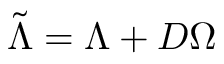Convert formula to latex. <formula><loc_0><loc_0><loc_500><loc_500>\tilde { \Lambda } = \Lambda + D \Omega</formula> 